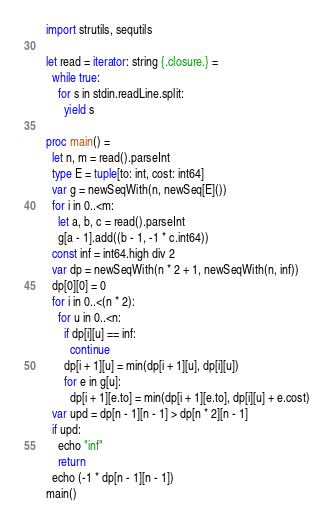<code> <loc_0><loc_0><loc_500><loc_500><_Nim_>import strutils, sequtils

let read = iterator: string {.closure.} =
  while true:
    for s in stdin.readLine.split:
      yield s

proc main() =
  let n, m = read().parseInt
  type E = tuple[to: int, cost: int64]
  var g = newSeqWith(n, newSeq[E]())
  for i in 0..<m:
    let a, b, c = read().parseInt
    g[a - 1].add((b - 1, -1 * c.int64))
  const inf = int64.high div 2
  var dp = newSeqWith(n * 2 + 1, newSeqWith(n, inf))
  dp[0][0] = 0
  for i in 0..<(n * 2):
    for u in 0..<n:
      if dp[i][u] == inf:
        continue
      dp[i + 1][u] = min(dp[i + 1][u], dp[i][u])
      for e in g[u]:
        dp[i + 1][e.to] = min(dp[i + 1][e.to], dp[i][u] + e.cost)
  var upd = dp[n - 1][n - 1] > dp[n * 2][n - 1]
  if upd:
    echo "inf"
    return
  echo (-1 * dp[n - 1][n - 1])
main()</code> 